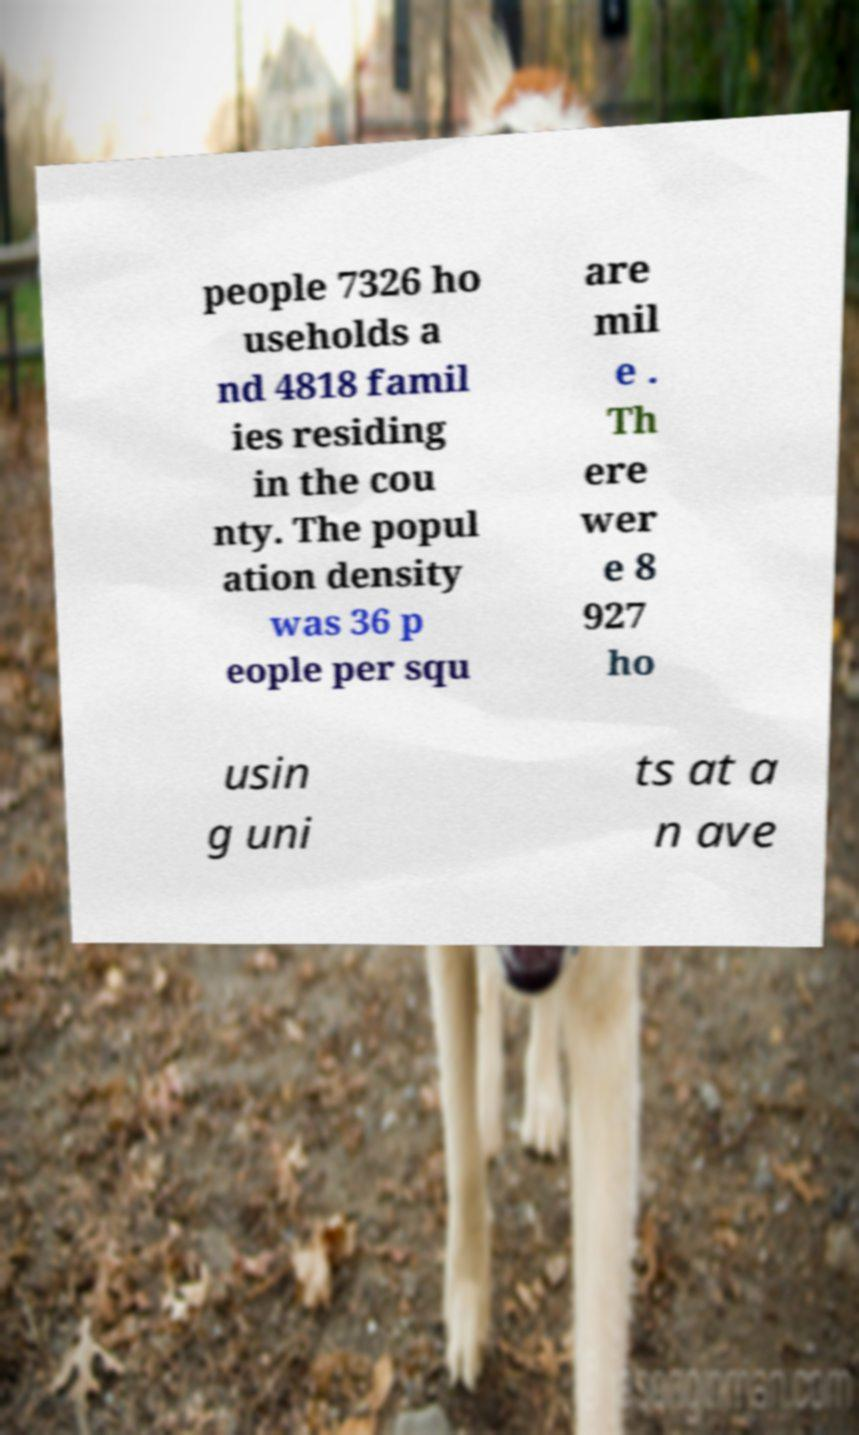Please identify and transcribe the text found in this image. people 7326 ho useholds a nd 4818 famil ies residing in the cou nty. The popul ation density was 36 p eople per squ are mil e . Th ere wer e 8 927 ho usin g uni ts at a n ave 